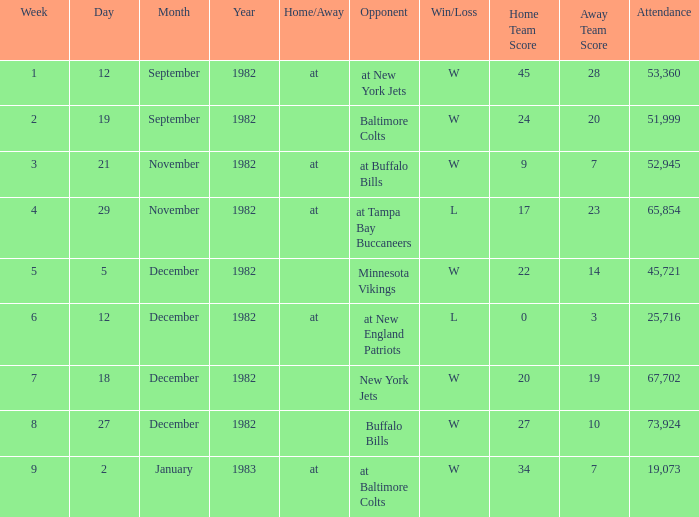What is the outcome of the game with a turnout exceeding 67,702? W 27–10. 